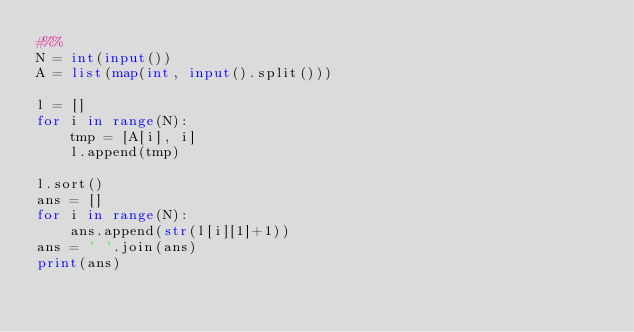Convert code to text. <code><loc_0><loc_0><loc_500><loc_500><_Python_>#%%
N = int(input())
A = list(map(int, input().split()))

l = []
for i in range(N):
    tmp = [A[i], i]
    l.append(tmp)

l.sort()
ans = []
for i in range(N):
    ans.append(str(l[i][1]+1))
ans = ' '.join(ans)
print(ans)</code> 